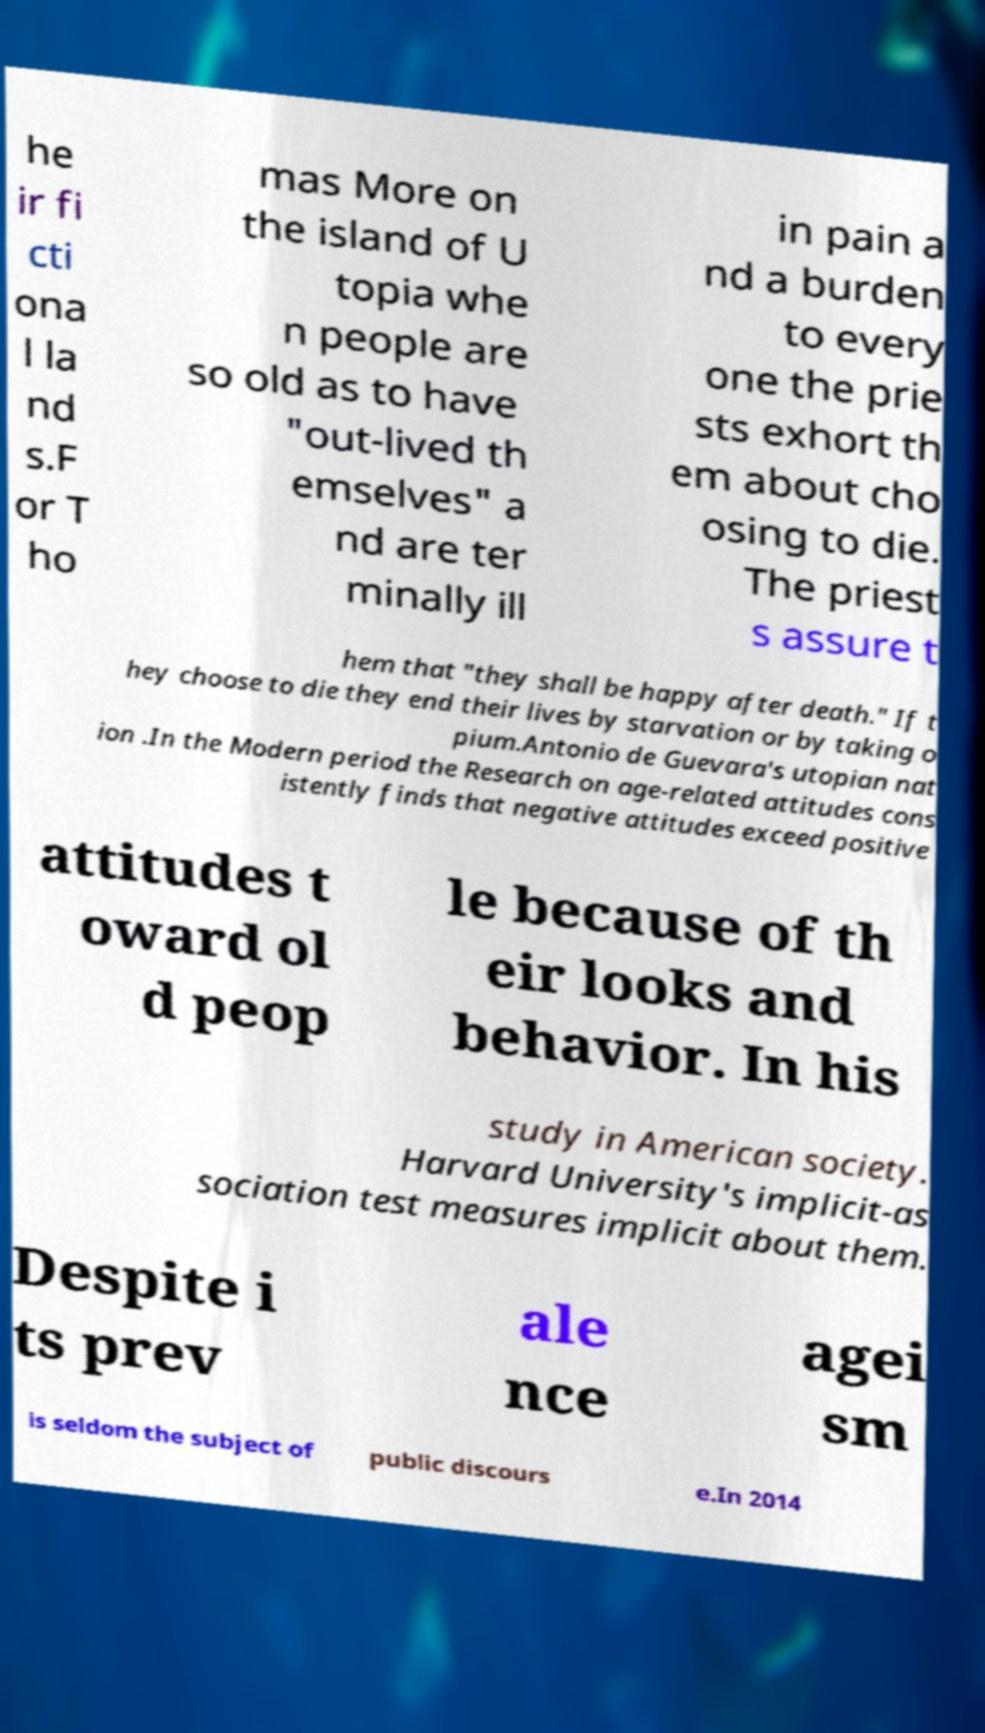Could you assist in decoding the text presented in this image and type it out clearly? he ir fi cti ona l la nd s.F or T ho mas More on the island of U topia whe n people are so old as to have "out-lived th emselves" a nd are ter minally ill in pain a nd a burden to every one the prie sts exhort th em about cho osing to die. The priest s assure t hem that "they shall be happy after death." If t hey choose to die they end their lives by starvation or by taking o pium.Antonio de Guevara's utopian nat ion .In the Modern period the Research on age-related attitudes cons istently finds that negative attitudes exceed positive attitudes t oward ol d peop le because of th eir looks and behavior. In his study in American society. Harvard University's implicit-as sociation test measures implicit about them. Despite i ts prev ale nce agei sm is seldom the subject of public discours e.In 2014 